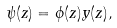<formula> <loc_0><loc_0><loc_500><loc_500>\psi ( z ) = \phi ( z ) y ( z ) ,</formula> 